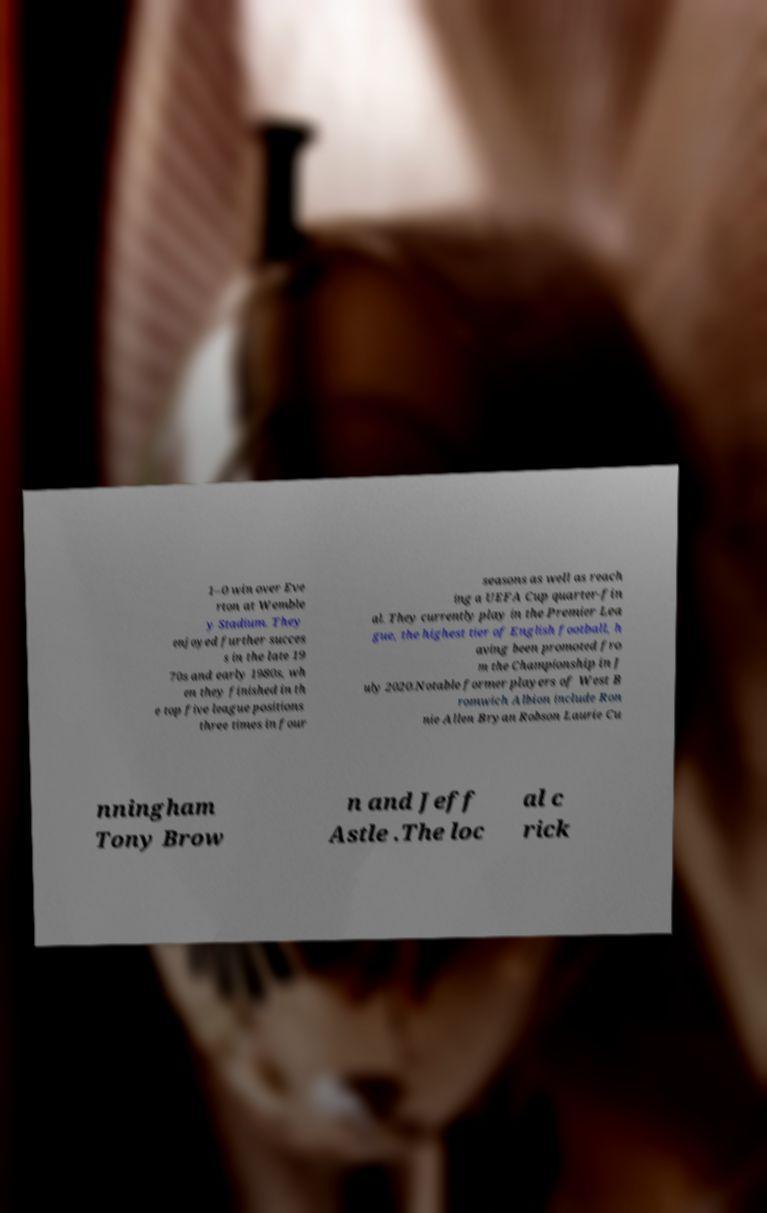For documentation purposes, I need the text within this image transcribed. Could you provide that? 1–0 win over Eve rton at Wemble y Stadium. They enjoyed further succes s in the late 19 70s and early 1980s, wh en they finished in th e top five league positions three times in four seasons as well as reach ing a UEFA Cup quarter-fin al. They currently play in the Premier Lea gue, the highest tier of English football, h aving been promoted fro m the Championship in J uly 2020.Notable former players of West B romwich Albion include Ron nie Allen Bryan Robson Laurie Cu nningham Tony Brow n and Jeff Astle .The loc al c rick 